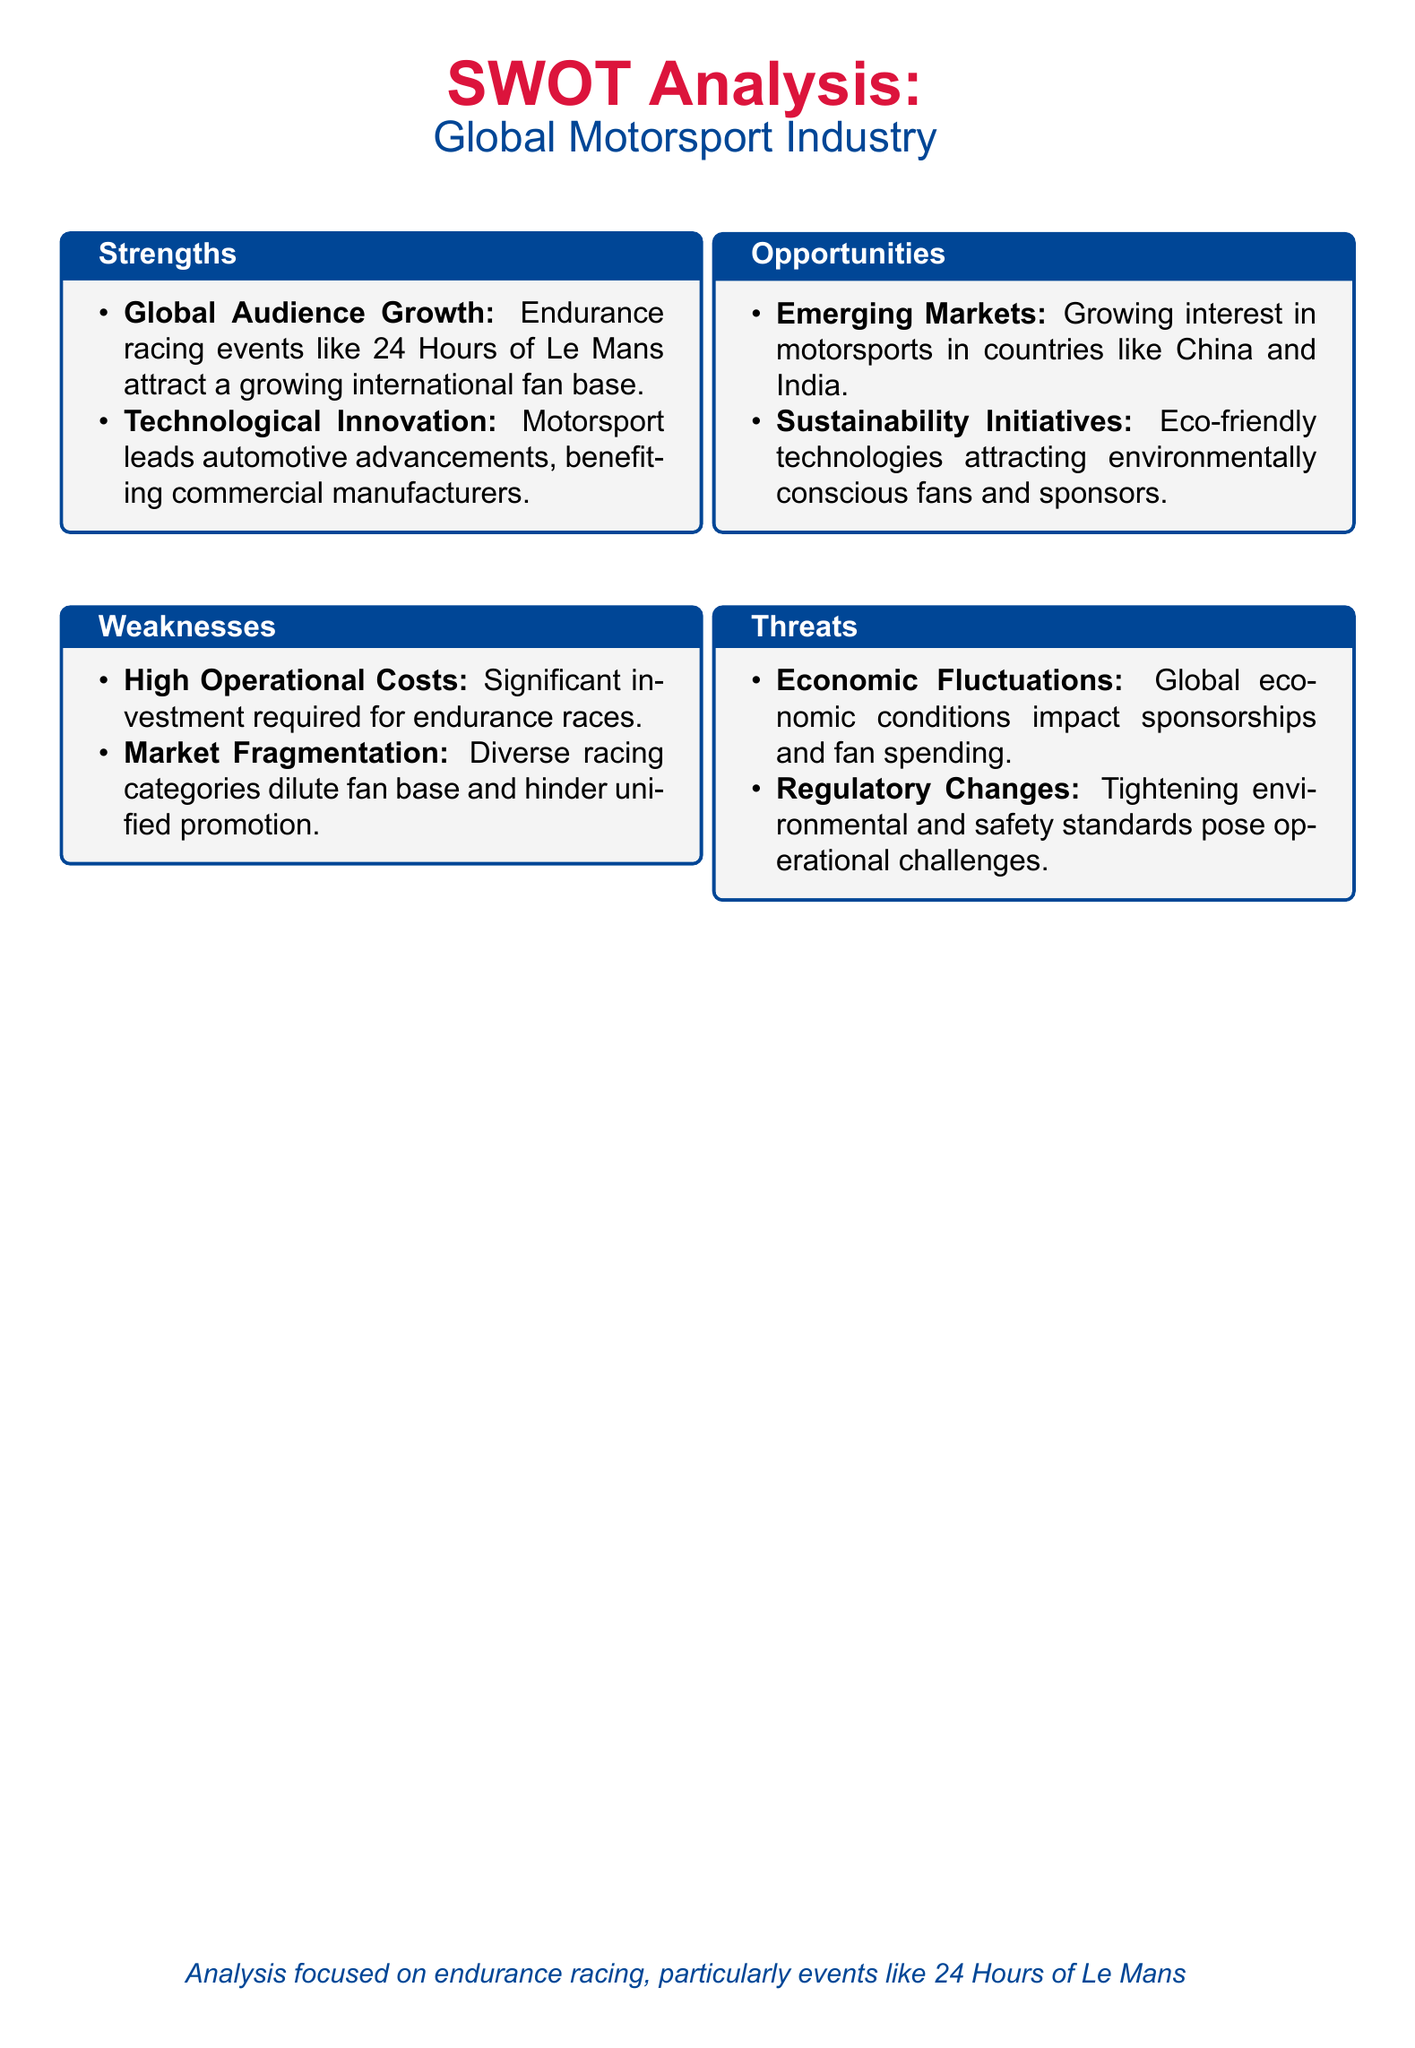what is a strength related to audience engagement? The document states that endurance racing events like the 24 Hours of Le Mans attract a growing international fan base, highlighting audience engagement as a strength.
Answer: Global Audience Growth what are two weaknesses mentioned in the document? The two weaknesses listed in the document are high operational costs and market fragmentation.
Answer: High Operational Costs; Market Fragmentation what is an opportunity for growth in the motorsport industry? The document indicates emerging markets, specifically mentioning countries like China and India, as an opportunity for growth.
Answer: Emerging Markets what threat is associated with economic conditions? The document cites economic fluctuations as a threat impacting sponsorships and fan spending.
Answer: Economic Fluctuations how many strengths are listed in the document? The document lists two strengths under the strengths section.
Answer: Two which racing event is particularly focused on in this analysis? The document emphasizes endurance racing events, specifically mentioning the 24 Hours of Le Mans.
Answer: 24 Hours of Le Mans what is a technological aspect mentioned as a strength? The document highlights that motorsport leads automotive advancements, benefiting commercial manufacturers.
Answer: Technological Innovation what is one sustainability-related opportunity mentioned? The document discusses sustainability initiatives as a means to attract environmentally conscious fans and sponsors.
Answer: Sustainability Initiatives what type of analysis is this document focused on? The document specifies that the analysis is focused on endurance racing, particularly events like the 24 Hours of Le Mans.
Answer: Endurance Racing 